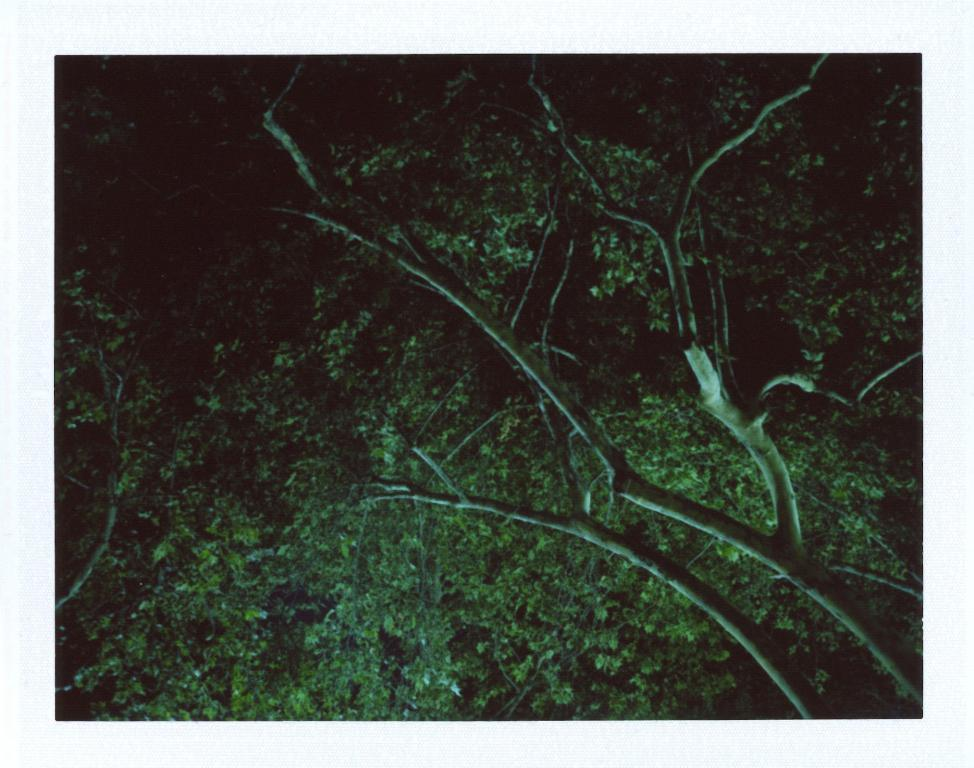What is the lighting condition in the image? The image is clicked in the dark. What can be seen in the image despite the dark lighting? There is a tree visible in the image. What type of salt is sprinkled on the tree in the image? There is no salt present in the image; it only features a tree in the dark. 